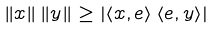Convert formula to latex. <formula><loc_0><loc_0><loc_500><loc_500>\left \| x \right \| \left \| y \right \| \geq \left | \left \langle x , e \right \rangle \left \langle e , y \right \rangle \right |</formula> 